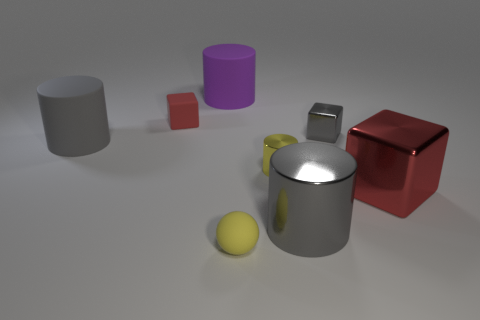Is there anything else of the same color as the sphere?
Provide a succinct answer. Yes. There is a object that is the same color as the matte block; what shape is it?
Provide a succinct answer. Cube. Do the small thing that is behind the small gray shiny thing and the shiny block on the right side of the small metal block have the same color?
Your answer should be compact. Yes. The big gray rubber thing that is to the left of the red matte object has what shape?
Offer a very short reply. Cylinder. What material is the big object behind the tiny object that is behind the small gray metal object?
Offer a very short reply. Rubber. Is there a rubber cylinder that has the same color as the small metallic cube?
Offer a terse response. Yes. Is the size of the yellow metallic object the same as the metal object that is in front of the big cube?
Offer a terse response. No. There is a large gray thing to the right of the matte object in front of the big metallic block; what number of yellow metallic cylinders are behind it?
Give a very brief answer. 1. How many gray matte things are behind the large metallic cylinder?
Provide a short and direct response. 1. What color is the small metal object behind the yellow thing that is right of the matte sphere?
Provide a short and direct response. Gray. 